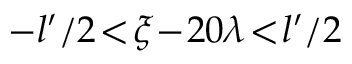<formula> <loc_0><loc_0><loc_500><loc_500>- l ^ { \prime } / 2 \, < \, \xi \, - \, 2 0 \lambda \, < \, l ^ { \prime } / 2</formula> 